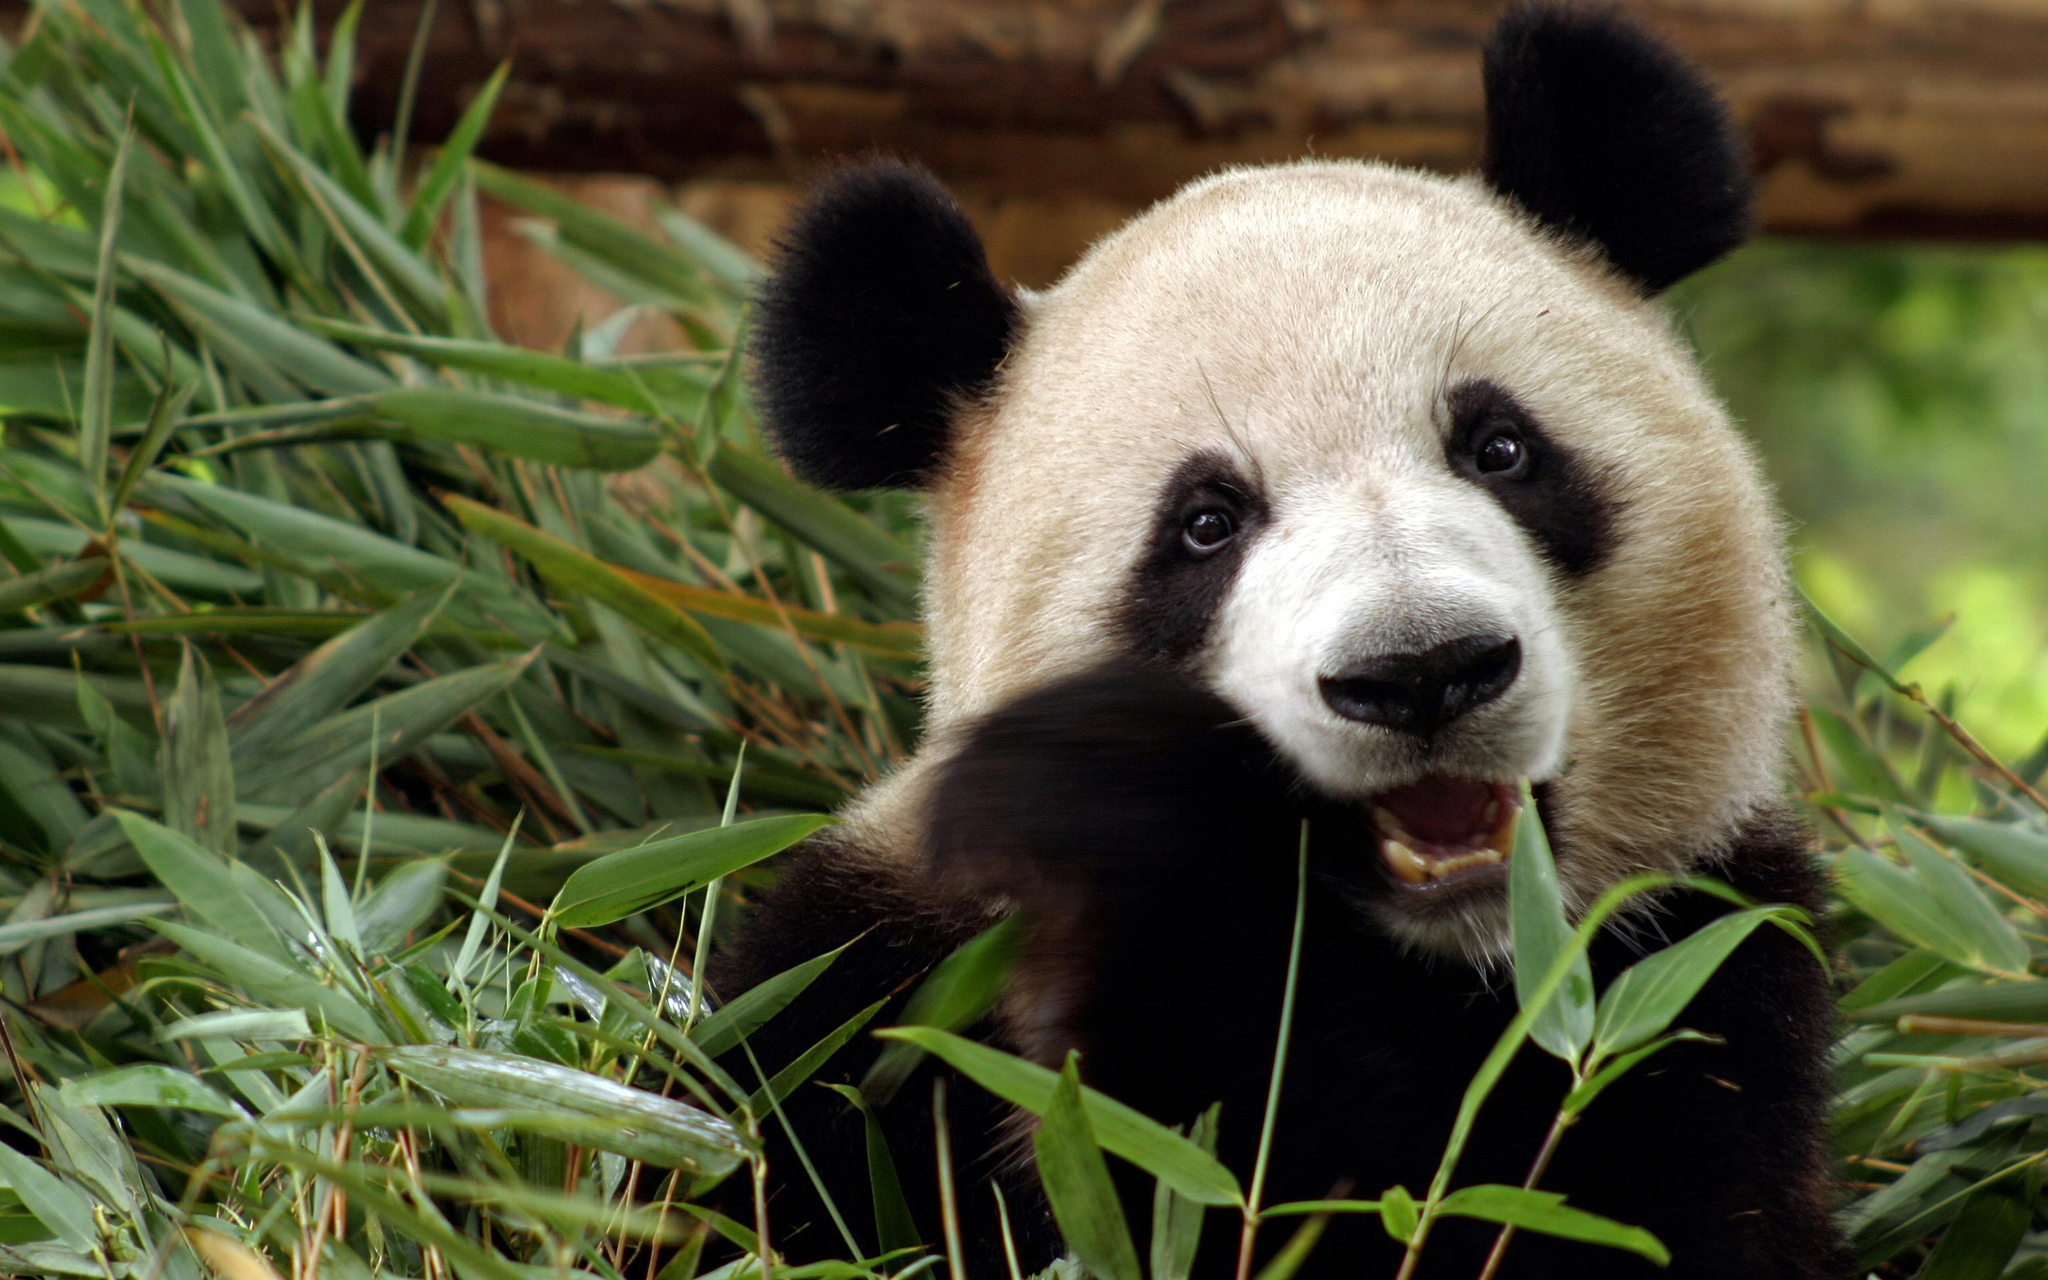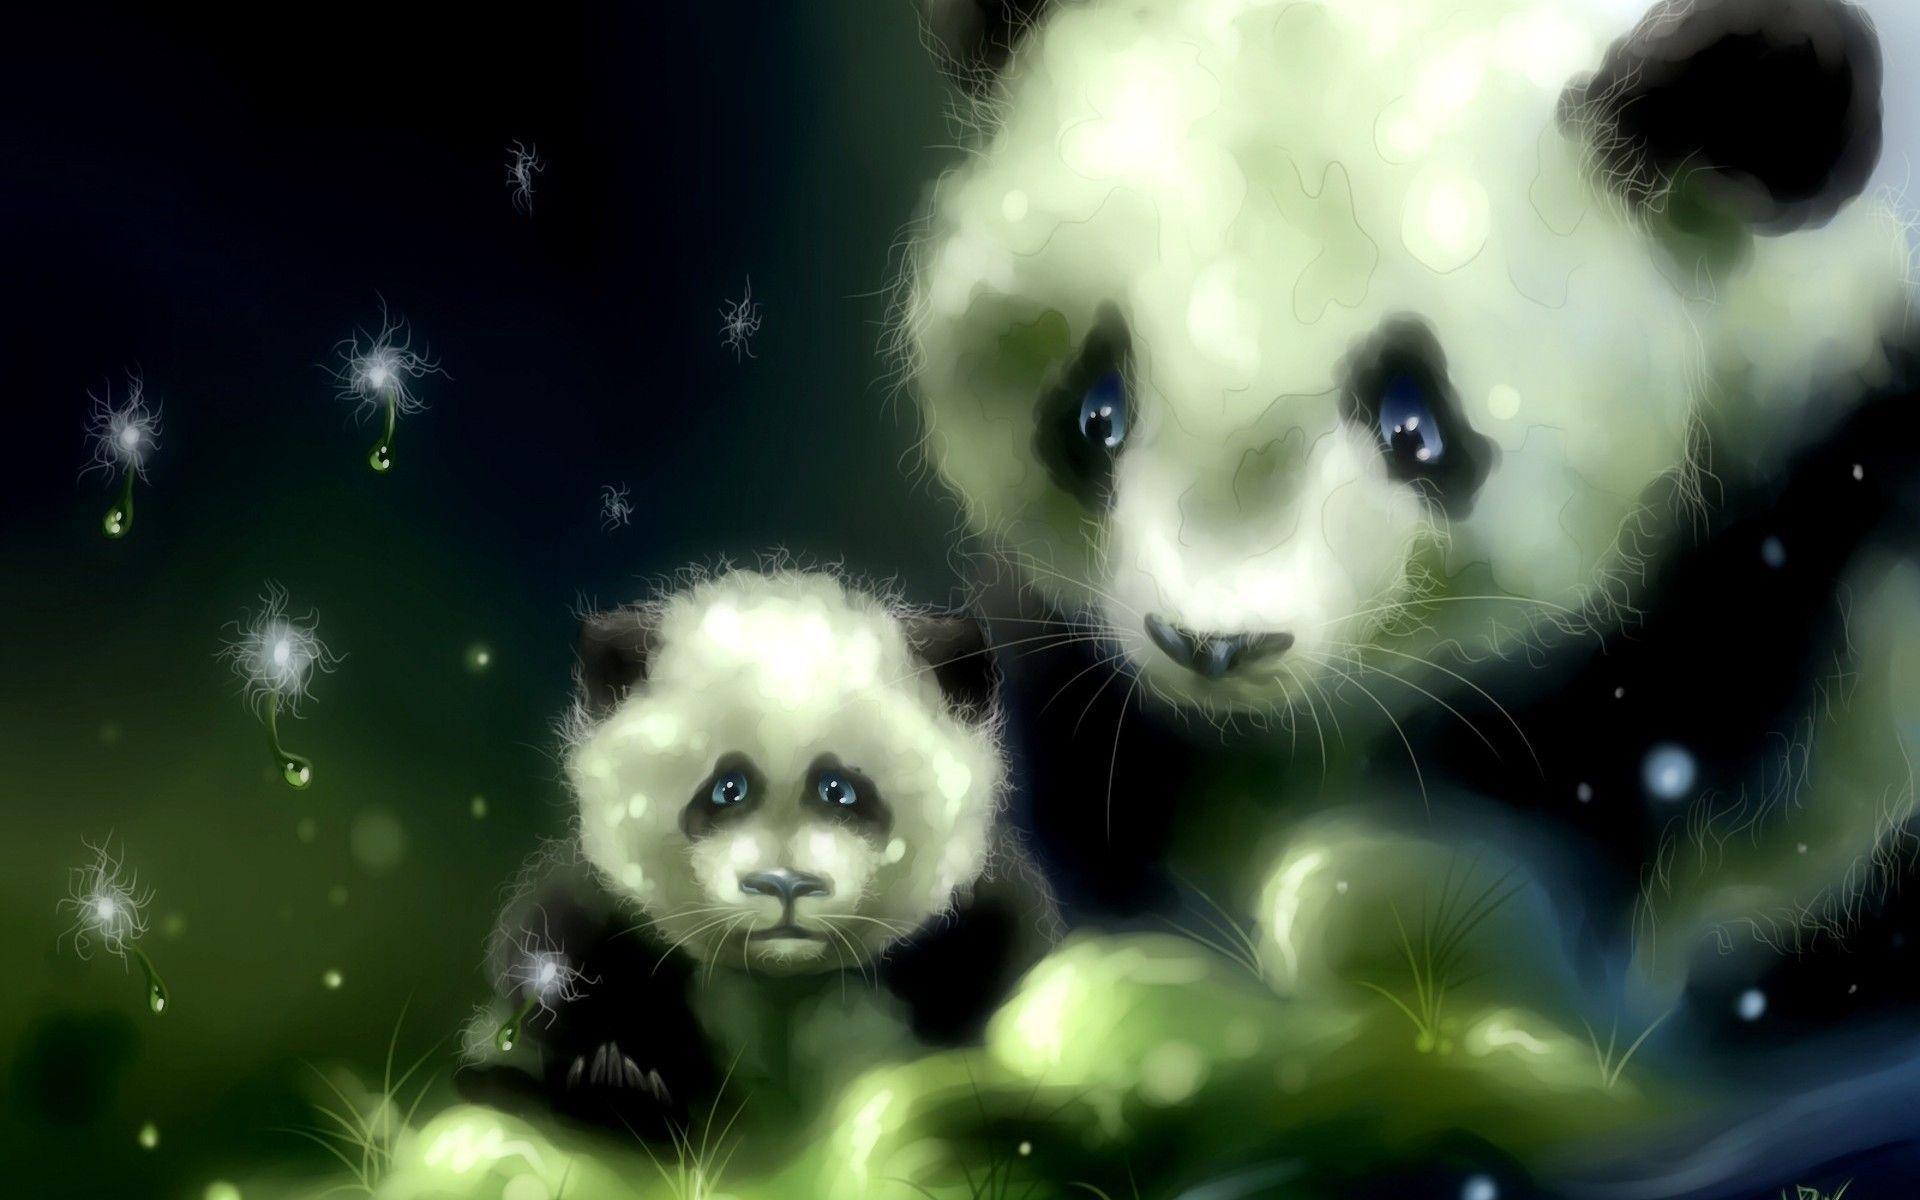The first image is the image on the left, the second image is the image on the right. Considering the images on both sides, is "The left and right image contains the same number of pandas." valid? Answer yes or no. No. 